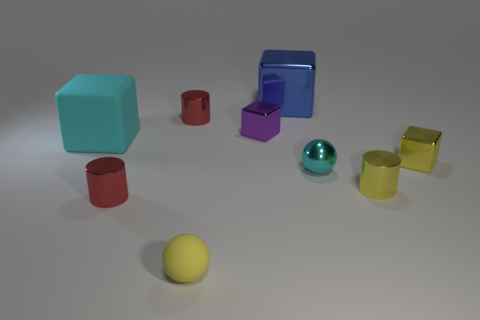Subtract all tiny yellow shiny cylinders. How many cylinders are left? 2 Subtract all blue cubes. How many cubes are left? 3 Subtract all cylinders. How many objects are left? 6 Subtract 3 cylinders. How many cylinders are left? 0 Subtract all cyan cylinders. How many red cubes are left? 0 Subtract all small yellow metal cylinders. Subtract all yellow cylinders. How many objects are left? 7 Add 8 small cyan metallic spheres. How many small cyan metallic spheres are left? 9 Add 6 tiny red cylinders. How many tiny red cylinders exist? 8 Subtract 0 gray spheres. How many objects are left? 9 Subtract all green blocks. Subtract all green cylinders. How many blocks are left? 4 